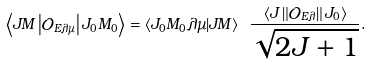Convert formula to latex. <formula><loc_0><loc_0><loc_500><loc_500>\left \langle J M \left | \mathcal { O } _ { E \lambda \mu } \right | J _ { 0 } M _ { 0 } \right \rangle = \left \langle J _ { 0 } M _ { 0 } \lambda \mu | J M \right \rangle \ \frac { \left \langle J \left \| \mathcal { O } _ { E \lambda } \right \| J _ { 0 } \right \rangle } { \sqrt { 2 J + 1 } } .</formula> 